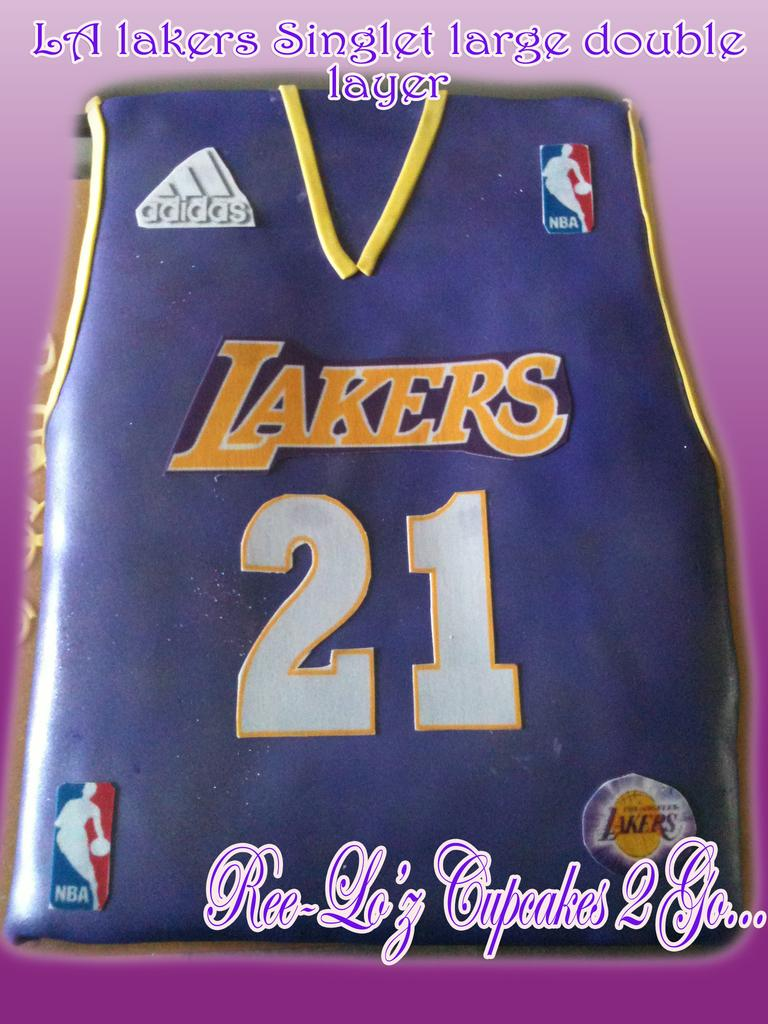Provide a one-sentence caption for the provided image. A cake from Ree Lo'z cupcakes 2 go is designed to look like the shirt of an LA Lakers player. 